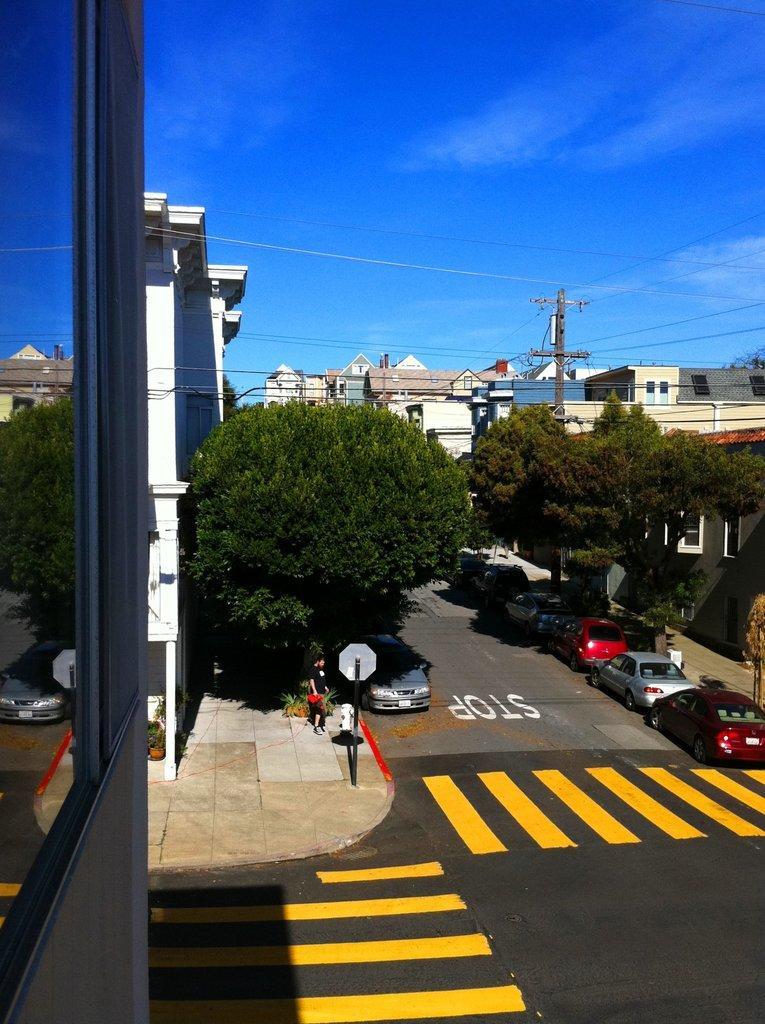Could you give a brief overview of what you see in this image? In the center of the image we can see the sky, clouds, wires, buildings, trees, poles, vehicles on the road, plant pots, plants, one person is standing and he is holding some object and a few other objects. 